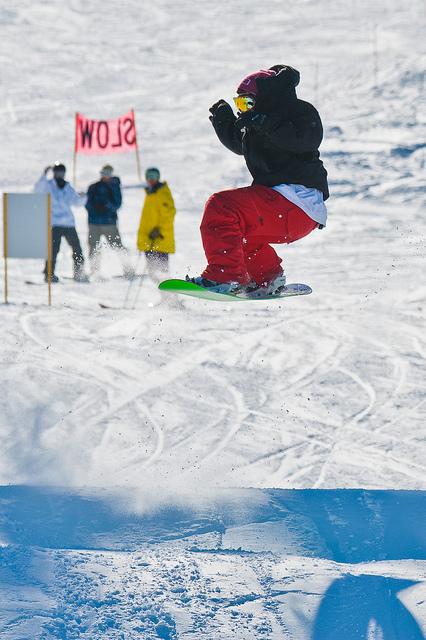What does the banner say?
Answer briefly. Slow. What color is the snow?
Short answer required. White. What is the person in red pants on?
Give a very brief answer. Snowboard. 